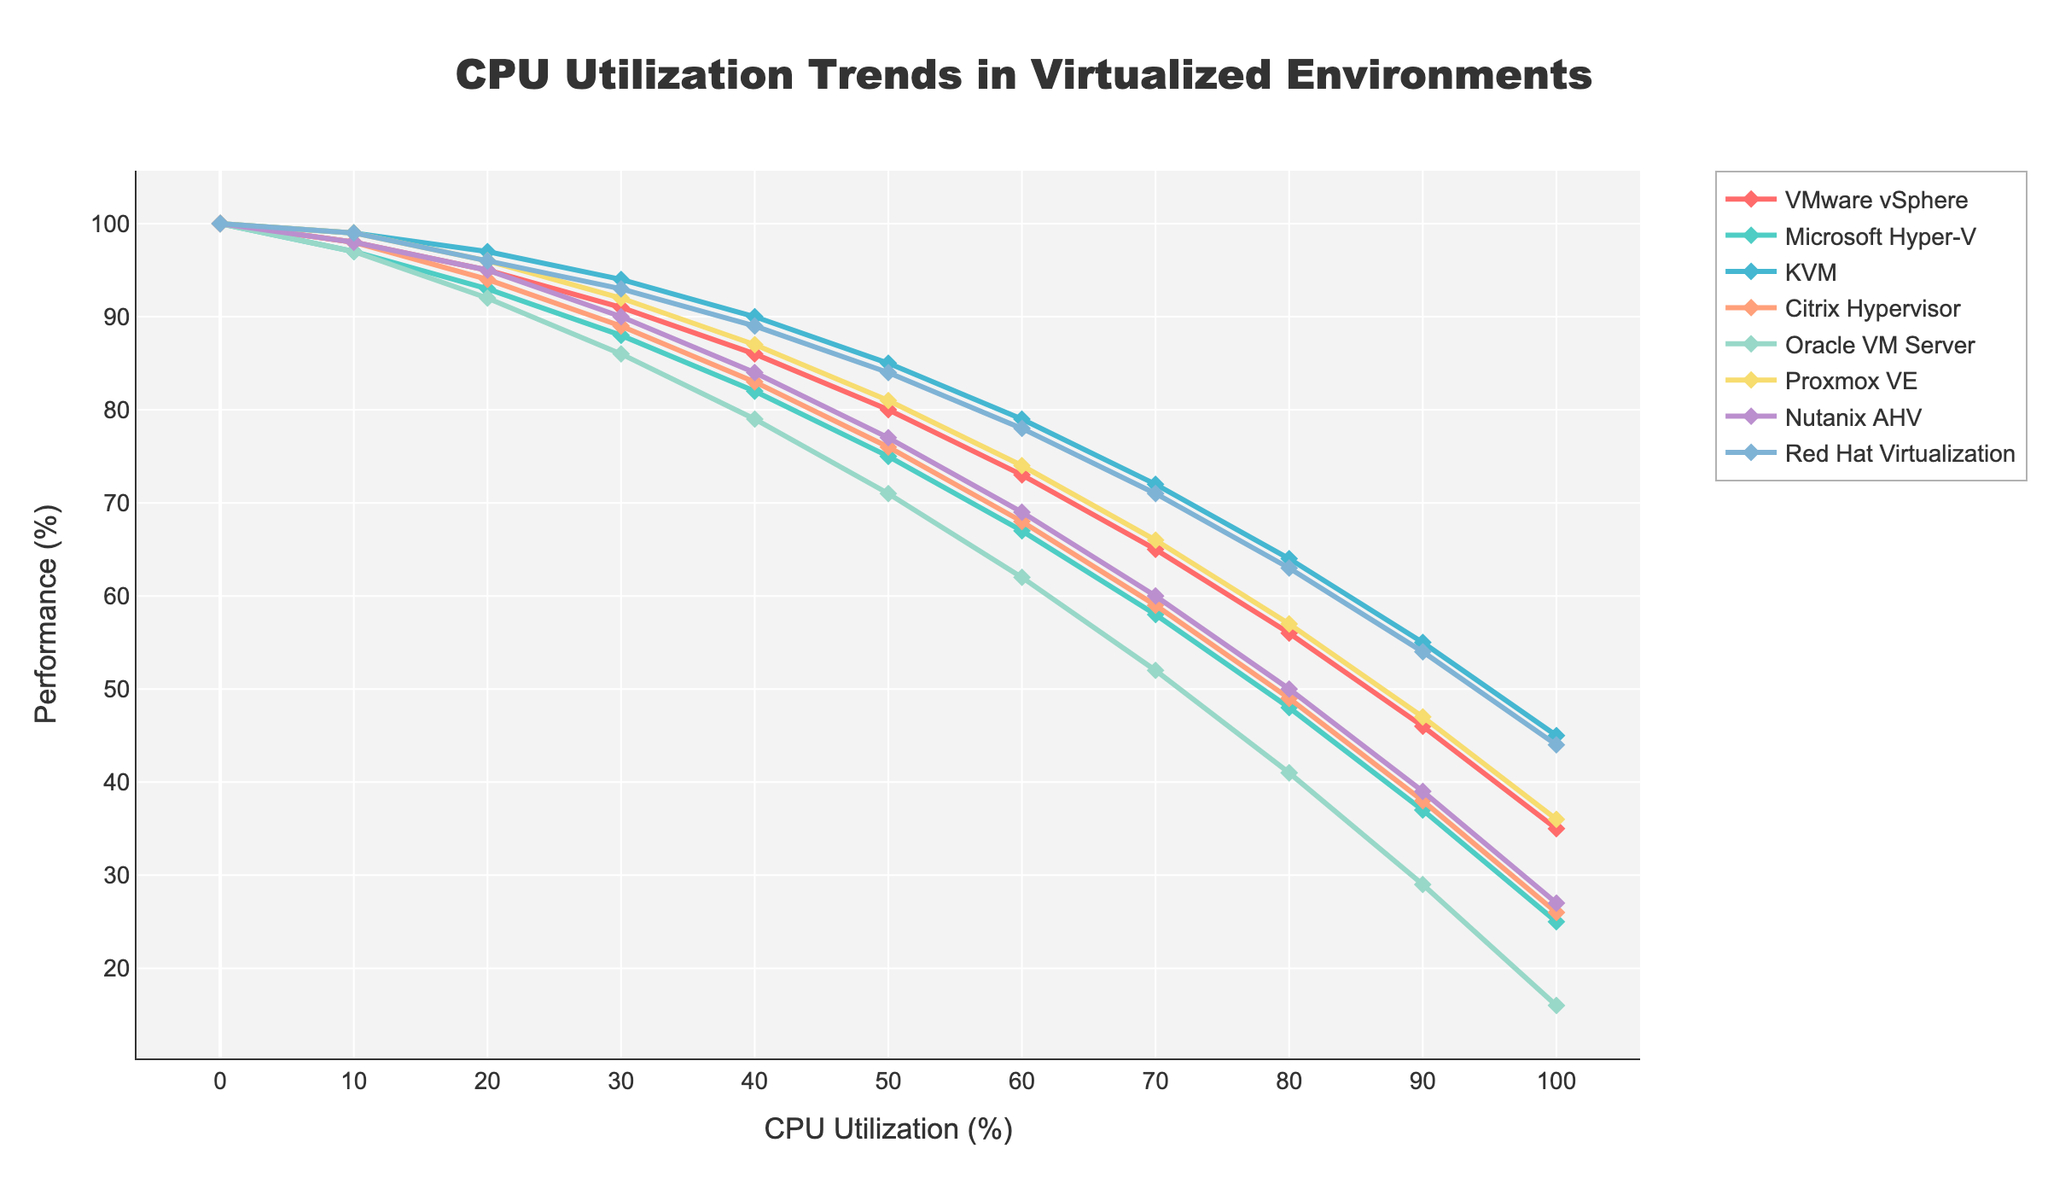What is the performance percentage of VMware vSphere at 50% CPU utilization? To find the performance percentage, look for VMware vSphere along the x-axis at 50% CPU utilization. The corresponding performance percentage is 80%.
Answer: 80% Which hypervisor shows the highest performance at 70% CPU utilization? To determine this, find 70% CPU utilization on the x-axis and compare the performance percentages of all hypervisors at this point. KVM shows the highest performance at 72%.
Answer: KVM At 90% CPU utilization, which hypervisor has the lowest performance? Find 90% CPU utilization on the x-axis and identify the performance percentages for all hypervisors. Oracle VM Server has the lowest performance at 29%.
Answer: Oracle VM Server What is the average performance of Red Hat Virtualization across all levels of CPU utilization? Add the performance values of Red Hat Virtualization across all CPU utilizations (100+99+96+93+89+84+78+71+63+54+44 = 871) and divide by the number of values (11). The average performance is 79.18%.
Answer: 79.18% At what CPU utilization level do VMware vSphere and Microsoft Hyper-V have the same performance percentage, and what is that percentage? Find the point on the x-axis where both VMware vSphere and Microsoft Hyper-V have the same value. They both intersect at 10% CPU utilization with a performance percentage of 97%.
Answer: 10%, 97% Between Nutanix AHV and Proxmox VE, which hypervisor has a better performance at 40% CPU utilization, and what are their respective performance percentages? Look at 40% CPU utilization on the x-axis and compare the performance percentages of Nutanix AHV (77%) and Proxmox VE (81%). Proxmox VE has better performance.
Answer: Proxmox VE, 77% and 81% Which hypervisor maintains a steady performance curve with minimal decline over increasing CPU utilization? Visually analyzing the curves, KVM maintains a relatively steady performance with minimal decline across increasing CPU utilization.
Answer: KVM What is the difference in performance at 80% CPU utilization between Citrix Hypervisor and Oracle VM Server? Find the performance percentages at 80% CPU utilization for Citrix Hypervisor (49%) and Oracle VM Server (41%), then subtract the smaller value from the larger value. The difference is 49%-41% = 8%.
Answer: 8% How does the performance of Microsoft Hyper-V at 90% CPU utilization compare to that of Red Hat Virtualization at 90% CPU utilization? Compare the performance values directly from the chart at 90% CPU utilization: Microsoft Hyper-V (37%) and Red Hat Virtualization (54%). Red Hat Virtualization performance is higher.
Answer: Red Hat Virtualization Between 60% and 80% CPU utilization, which hypervisor shows the largest drop in performance, and what are the performance drops for each hypervisor? Check the performance values at 60% and 80% CPU utilization for each hypervisor, then find the difference: VMware vSphere (73%-56%=17%), Microsoft Hyper-V (67%-48%=19%), KVM (79%-64%=15%), Citrix Hypervisor (68%-49%=19%), Oracle VM Server (62%-41%=21%), Proxmox VE (74%-57%=17%), Nutanix AHV (69%-50%=19%), Red Hat Virtualization (78%-63%=15%). Oracle VM Server shows the largest drop of 21%.
Answer: Oracle VM Server, largest drop 21% 